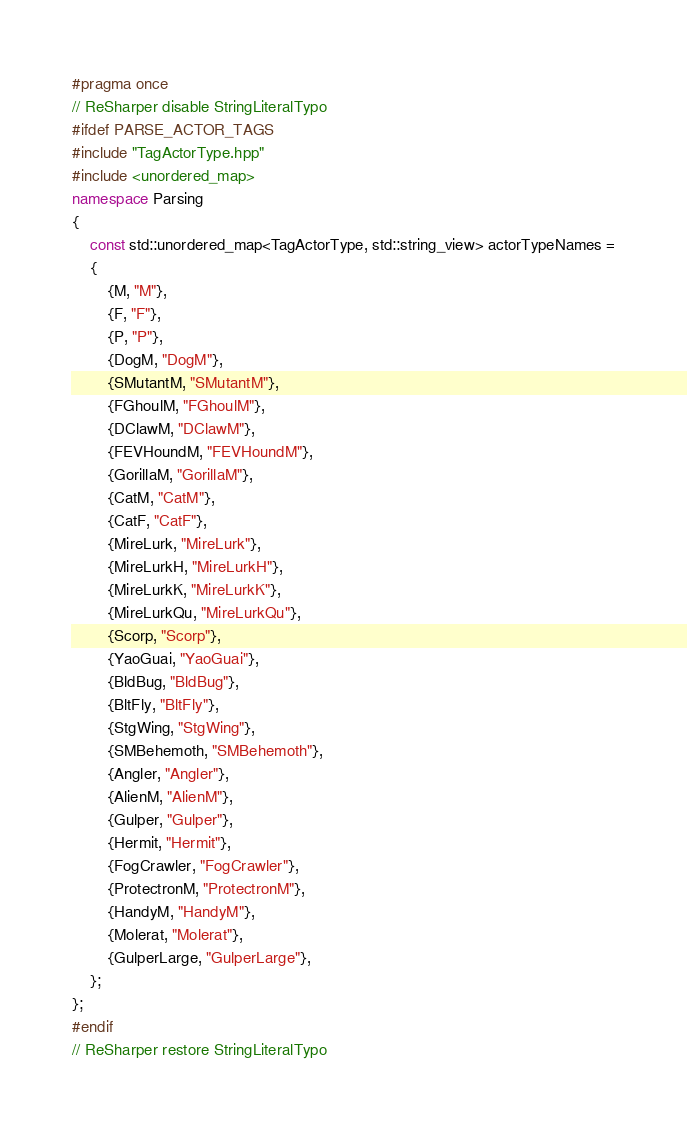Convert code to text. <code><loc_0><loc_0><loc_500><loc_500><_C++_>#pragma once
// ReSharper disable StringLiteralTypo
#ifdef PARSE_ACTOR_TAGS
#include "TagActorType.hpp"
#include <unordered_map>
namespace Parsing
{
	const std::unordered_map<TagActorType, std::string_view> actorTypeNames =
	{
		{M, "M"},
		{F, "F"},
		{P, "P"},
		{DogM, "DogM"},
		{SMutantM, "SMutantM"},
		{FGhoulM, "FGhoulM"},
		{DClawM, "DClawM"},
		{FEVHoundM, "FEVHoundM"},
		{GorillaM, "GorillaM"},
		{CatM, "CatM"},
		{CatF, "CatF"},
		{MireLurk, "MireLurk"},
		{MireLurkH, "MireLurkH"},
		{MireLurkK, "MireLurkK"},
		{MireLurkQu, "MireLurkQu"},
		{Scorp, "Scorp"},
		{YaoGuai, "YaoGuai"},
		{BldBug, "BldBug"},
		{BltFly, "BltFly"},
		{StgWing, "StgWing"},
		{SMBehemoth, "SMBehemoth"},
		{Angler, "Angler"},
		{AlienM, "AlienM"},
		{Gulper, "Gulper"},
		{Hermit, "Hermit"},
		{FogCrawler, "FogCrawler"},
		{ProtectronM, "ProtectronM"},
		{HandyM, "HandyM"},
		{Molerat, "Molerat"},
		{GulperLarge, "GulperLarge"},
	};
};
#endif
// ReSharper restore StringLiteralTypo</code> 